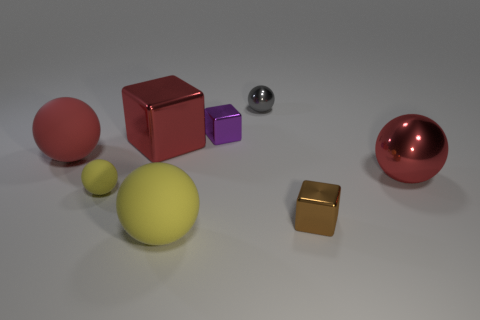Subtract all gray spheres. How many spheres are left? 4 Subtract all small yellow balls. How many balls are left? 4 Subtract 2 balls. How many balls are left? 3 Subtract all purple balls. Subtract all green blocks. How many balls are left? 5 Add 1 matte blocks. How many objects exist? 9 Subtract all balls. How many objects are left? 3 Subtract 0 purple balls. How many objects are left? 8 Subtract all small metal cubes. Subtract all gray things. How many objects are left? 5 Add 5 tiny yellow rubber things. How many tiny yellow rubber things are left? 6 Add 2 big green metal cylinders. How many big green metal cylinders exist? 2 